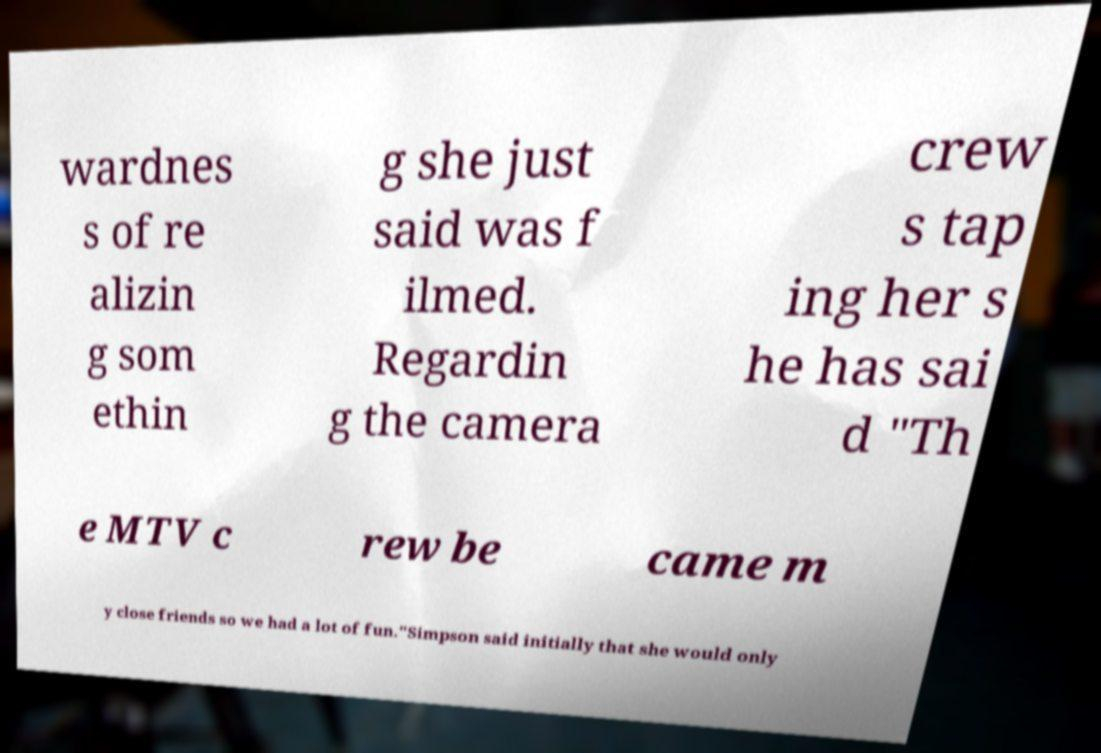I need the written content from this picture converted into text. Can you do that? wardnes s of re alizin g som ethin g she just said was f ilmed. Regardin g the camera crew s tap ing her s he has sai d "Th e MTV c rew be came m y close friends so we had a lot of fun."Simpson said initially that she would only 